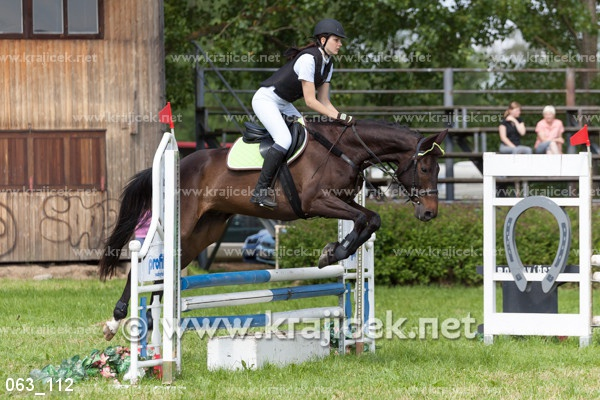Describe the objects in this image and their specific colors. I can see horse in gray, black, and maroon tones, people in gray, black, white, and tan tones, people in gray, black, darkgray, lightgray, and pink tones, people in gray, pink, lightpink, and darkgray tones, and bench in gray, black, and darkgreen tones in this image. 